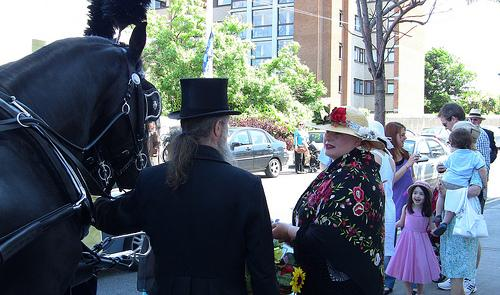Identify the color and type of dress the young girl in the image is wearing. The young girl is wearing a pink dress. What type of clothing item does the woman have on her shoulders? The woman is wearing a red and black shawl on her shoulders. What object is located near the woman and has a yellow color? A yellow sunflower is located near the woman. Portray a scene of interaction between objects in the image. A woman wearing a tan hat with a red flower on it and a red and black shawl is standing near a man holding a black horse, while a young girl wearing a pink dress is nearby. What gesture is the man making with the horse in the image? The man is holding a black horse in the image. What type of clothing item are both the man and the woman wearing separately in the image? Both the woman and the man are wearing black jackets. Determine the sentiment evoked by the image based on the objects and their interactions. The image evokes a sense of togetherness, as various people and objects are gathered in a scene, possibly at an outdoor event or gathering. Can you tell me the dominant color of the hat worn by the woman in the image? The dominant color of the woman's hat is tan. Count the number of green covers on the fences in the image. There are 9 green covers on the fences. What is the color and type of vehicle behind the man in the image? There is a black car behind the man in the image. What is the condition of the fence in the image? Cannot determine, only green covers on the fence are visible. Which object corresponds to the description “a young girl with brown hair”? Which object corresponds to the image information “a young girl with brown hair”? Provide a short caption for the given image. A man holding a black horse, a woman with a tan hat, and a girl in a pink dress gather near fence. Is there text visible in the image? No List all objects visible within the given image. woman, tan hat, red flower, red and black shawl, black jacket, man, black horse, black car, yellow sunflower, girl, pink dress, green cover, fence, young child, long hair. Is the car behind the man black or red? Black Identify any unusual or unexpected elements in the image. There are multiple green covers on the fence, which might be considered unusual. Who is wearing a hat with a red flower on it? The woman In the image, how many times does the green cover appear on the fence? 11 What is the sentiment portrayed in the image? Positive, as it displays people and various objects in a likely social environment. State the position and size of the yellow sunflower. Position - X:274, Y:259; Size - Width:29, Height:29 How do the man, woman, and horse interact in the image? The man holds the black horse, while the woman is near them, alluding to a social interaction. What kind of print does the woman's shawl have? Floral What kind of hat is the man wearing? Black hat What is the color of the shawl the woman is wearing in the image? Red and black What is the woman holding in the image? The woman is not holding anything. What color is the girl's dress in the image? Pink 